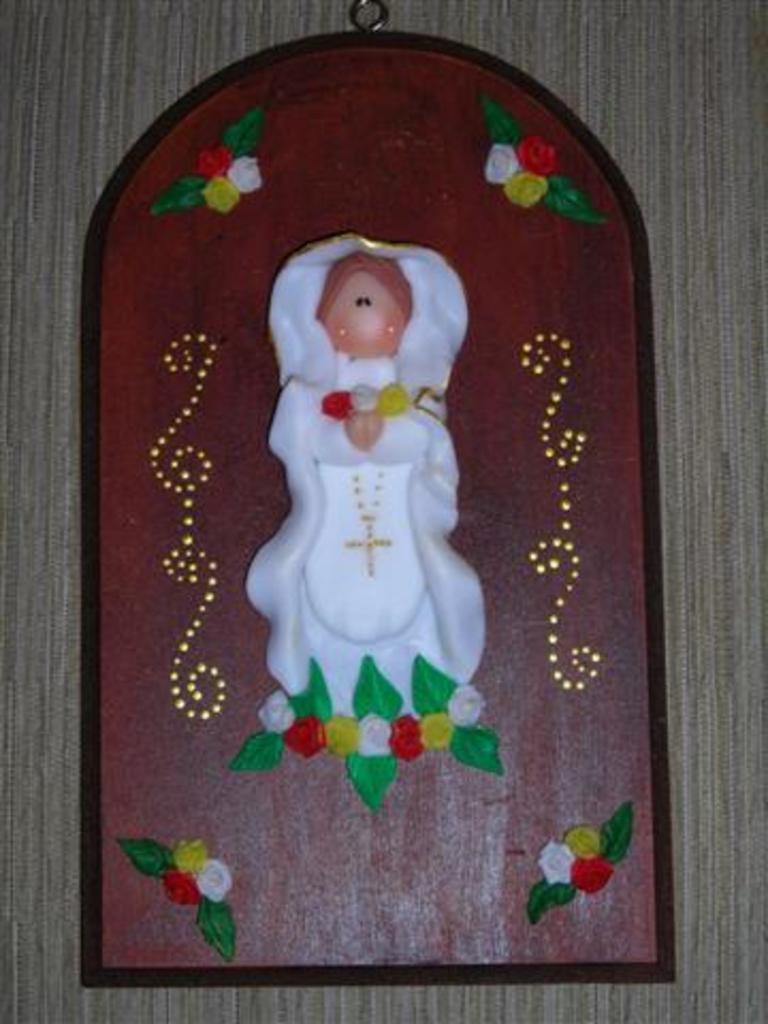How would you summarize this image in a sentence or two? In this image we can see there is a frame hanging on the wall. 